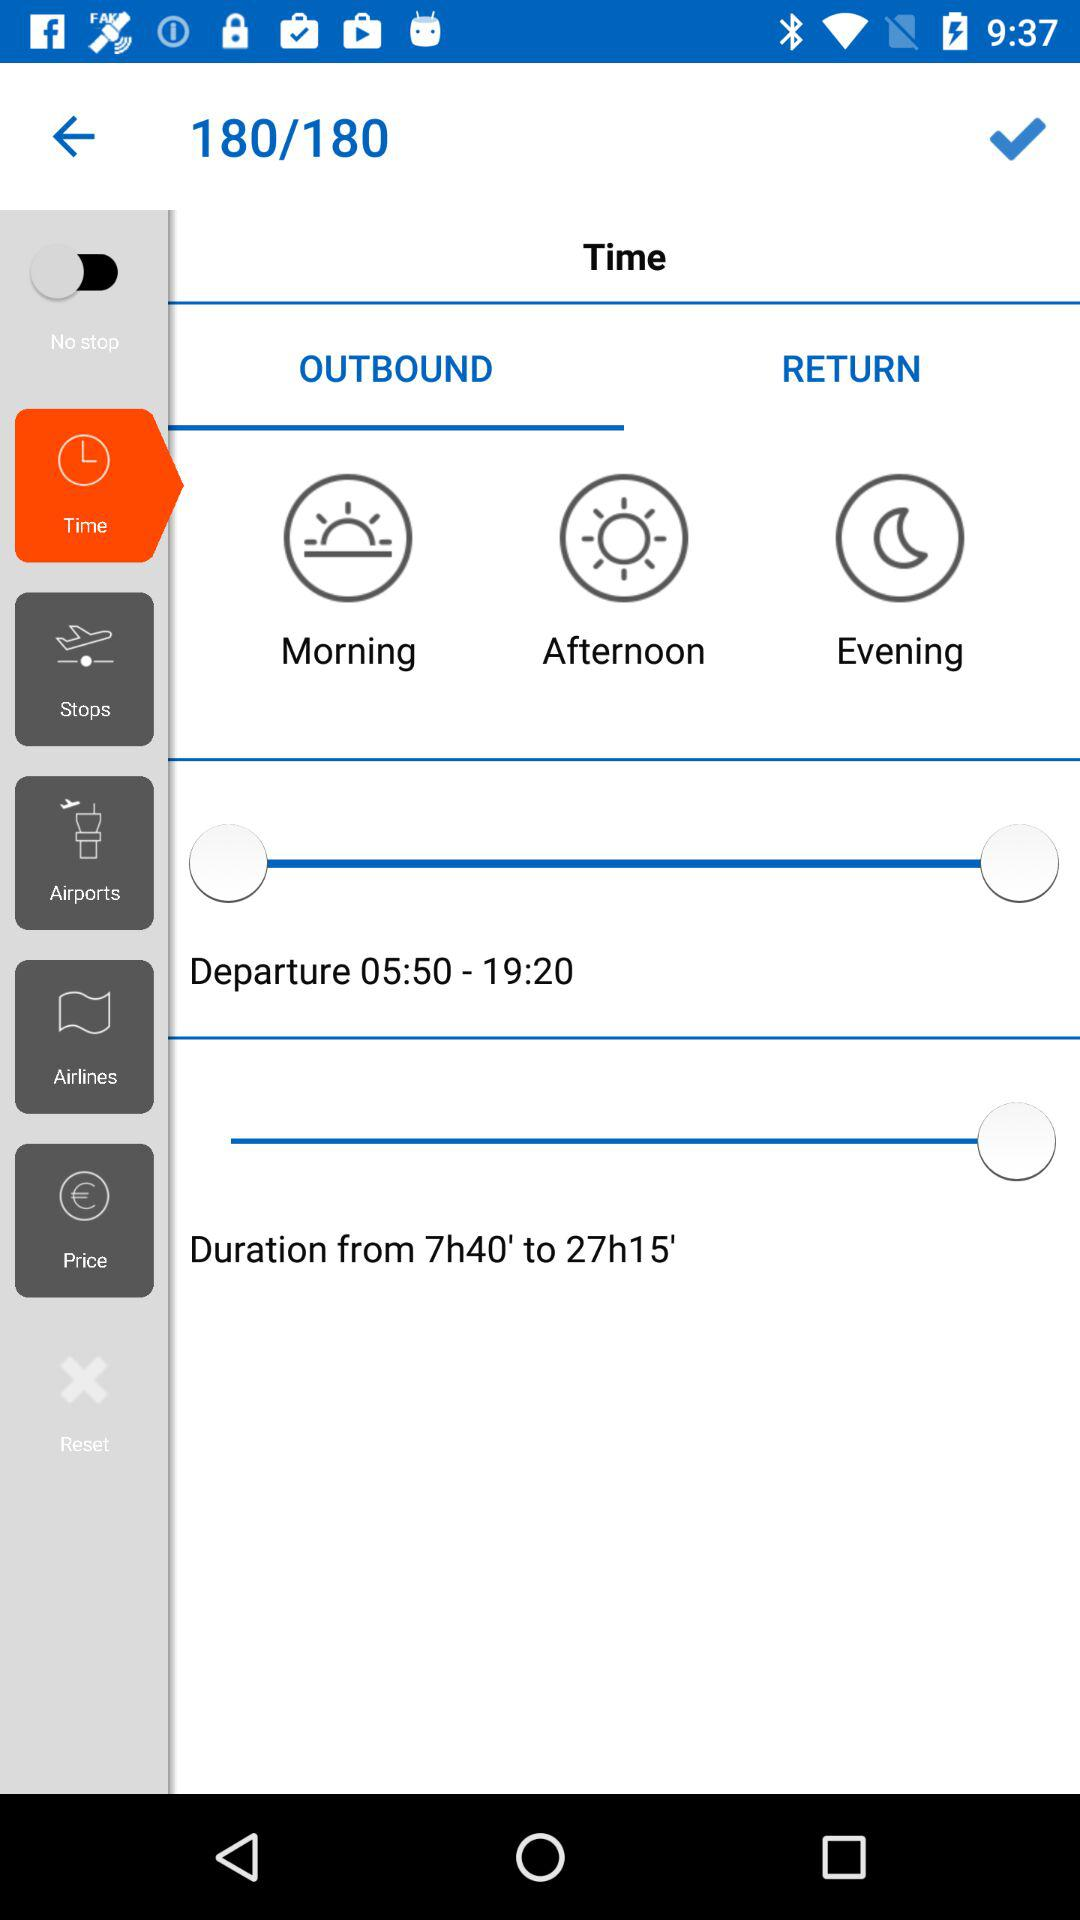What is the travel time duration? The travel time ranges from 7h40' to 27h15'. 